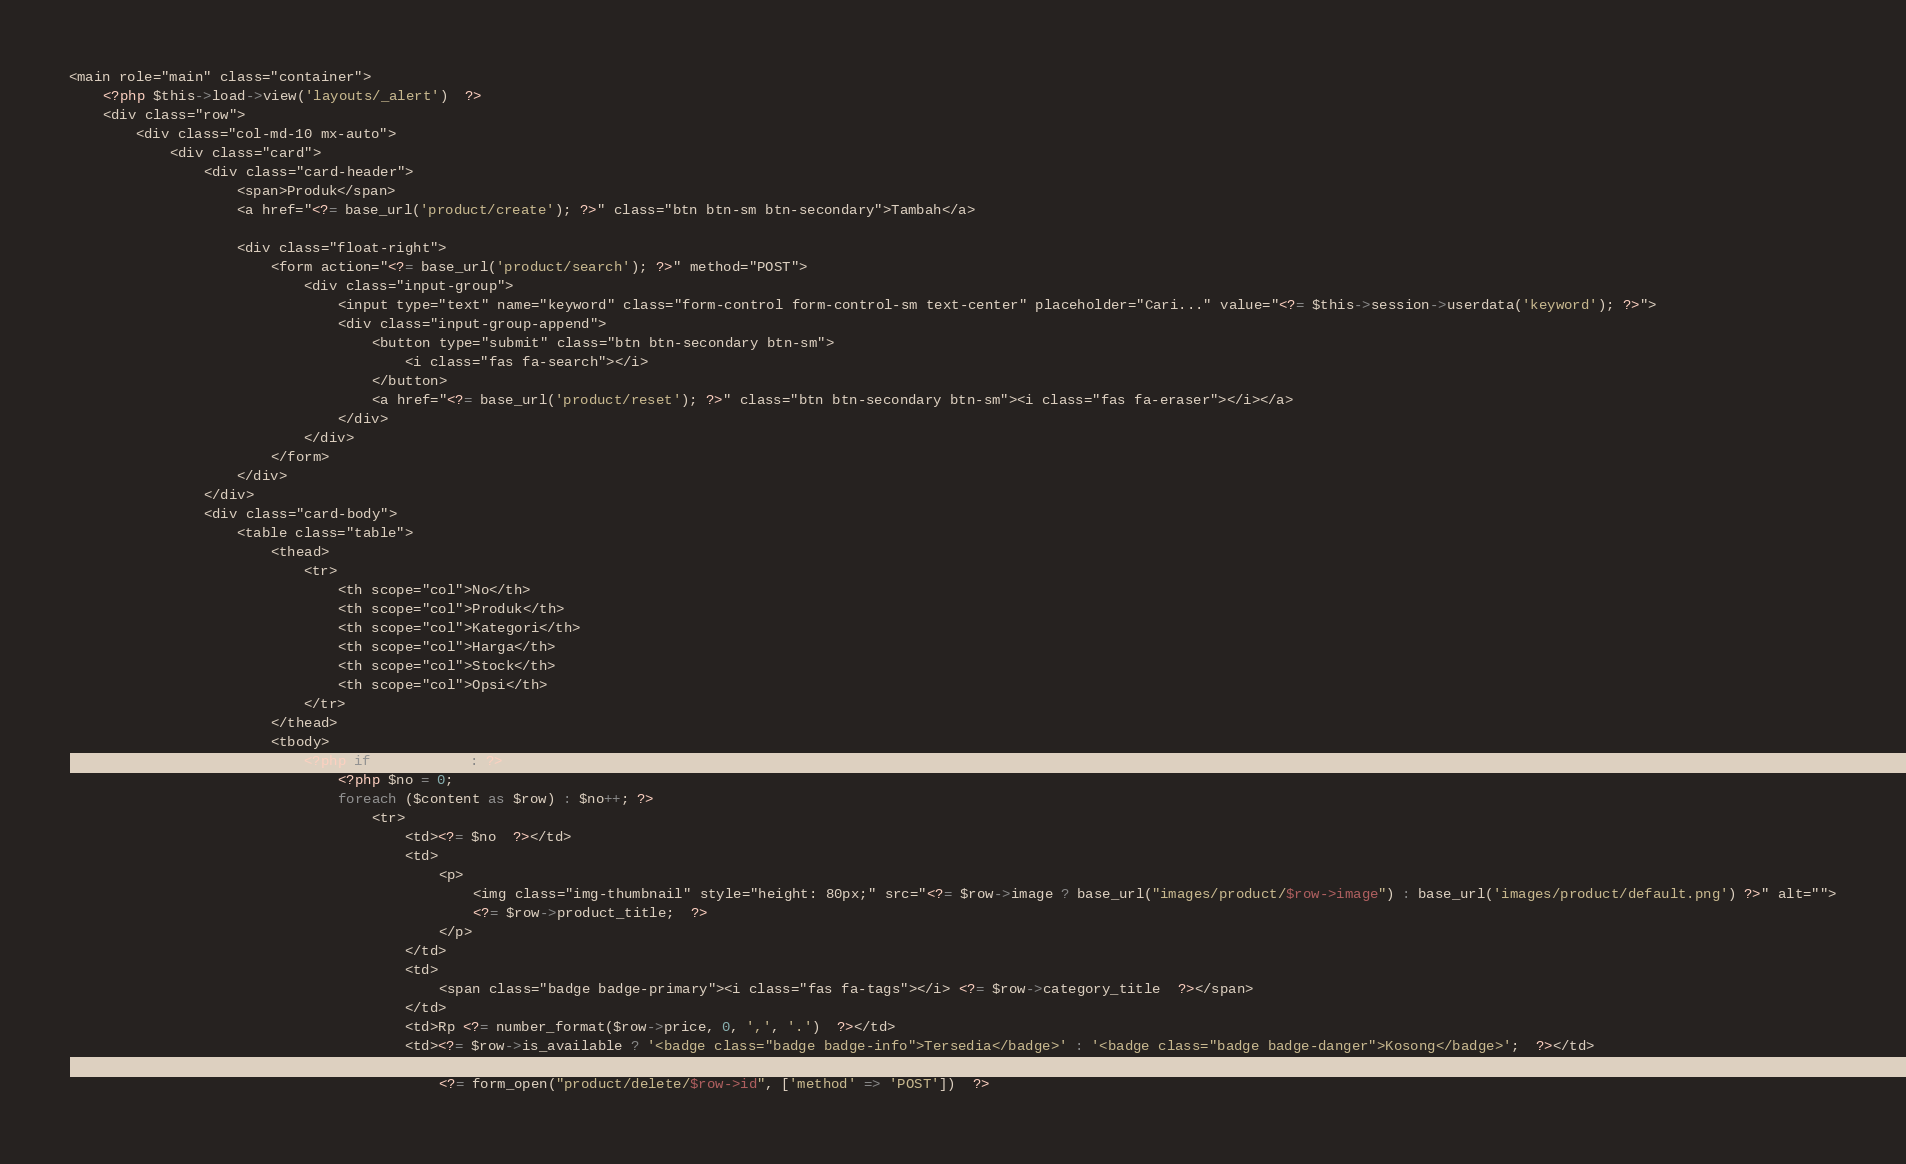<code> <loc_0><loc_0><loc_500><loc_500><_PHP_><main role="main" class="container">
    <?php $this->load->view('layouts/_alert')  ?>
    <div class="row">
        <div class="col-md-10 mx-auto">
            <div class="card">
                <div class="card-header">
                    <span>Produk</span>
                    <a href="<?= base_url('product/create'); ?>" class="btn btn-sm btn-secondary">Tambah</a>

                    <div class="float-right">
                        <form action="<?= base_url('product/search'); ?>" method="POST">
                            <div class="input-group">
                                <input type="text" name="keyword" class="form-control form-control-sm text-center" placeholder="Cari..." value="<?= $this->session->userdata('keyword'); ?>">
                                <div class="input-group-append">
                                    <button type="submit" class="btn btn-secondary btn-sm">
                                        <i class="fas fa-search"></i>
                                    </button>
                                    <a href="<?= base_url('product/reset'); ?>" class="btn btn-secondary btn-sm"><i class="fas fa-eraser"></i></a>
                                </div>
                            </div>
                        </form>
                    </div>
                </div>
                <div class="card-body">
                    <table class="table">
                        <thead>
                            <tr>
                                <th scope="col">No</th>
                                <th scope="col">Produk</th>
                                <th scope="col">Kategori</th>
                                <th scope="col">Harga</th>
                                <th scope="col">Stock</th>
                                <th scope="col">Opsi</th>
                            </tr>
                        </thead>
                        <tbody>
                            <?php if ($content) : ?>
                                <?php $no = 0;
                                foreach ($content as $row) : $no++; ?>
                                    <tr>
                                        <td><?= $no  ?></td>
                                        <td>
                                            <p>
                                                <img class="img-thumbnail" style="height: 80px;" src="<?= $row->image ? base_url("images/product/$row->image") : base_url('images/product/default.png') ?>" alt="">
                                                <?= $row->product_title;  ?>
                                            </p>
                                        </td>
                                        <td>
                                            <span class="badge badge-primary"><i class="fas fa-tags"></i> <?= $row->category_title  ?></span>
                                        </td>
                                        <td>Rp <?= number_format($row->price, 0, ',', '.')  ?></td>
                                        <td><?= $row->is_available ? '<badge class="badge badge-info">Tersedia</badge>' : '<badge class="badge badge-danger">Kosong</badge>';  ?></td>
                                        <td>
                                            <?= form_open("product/delete/$row->id", ['method' => 'POST'])  ?></code> 